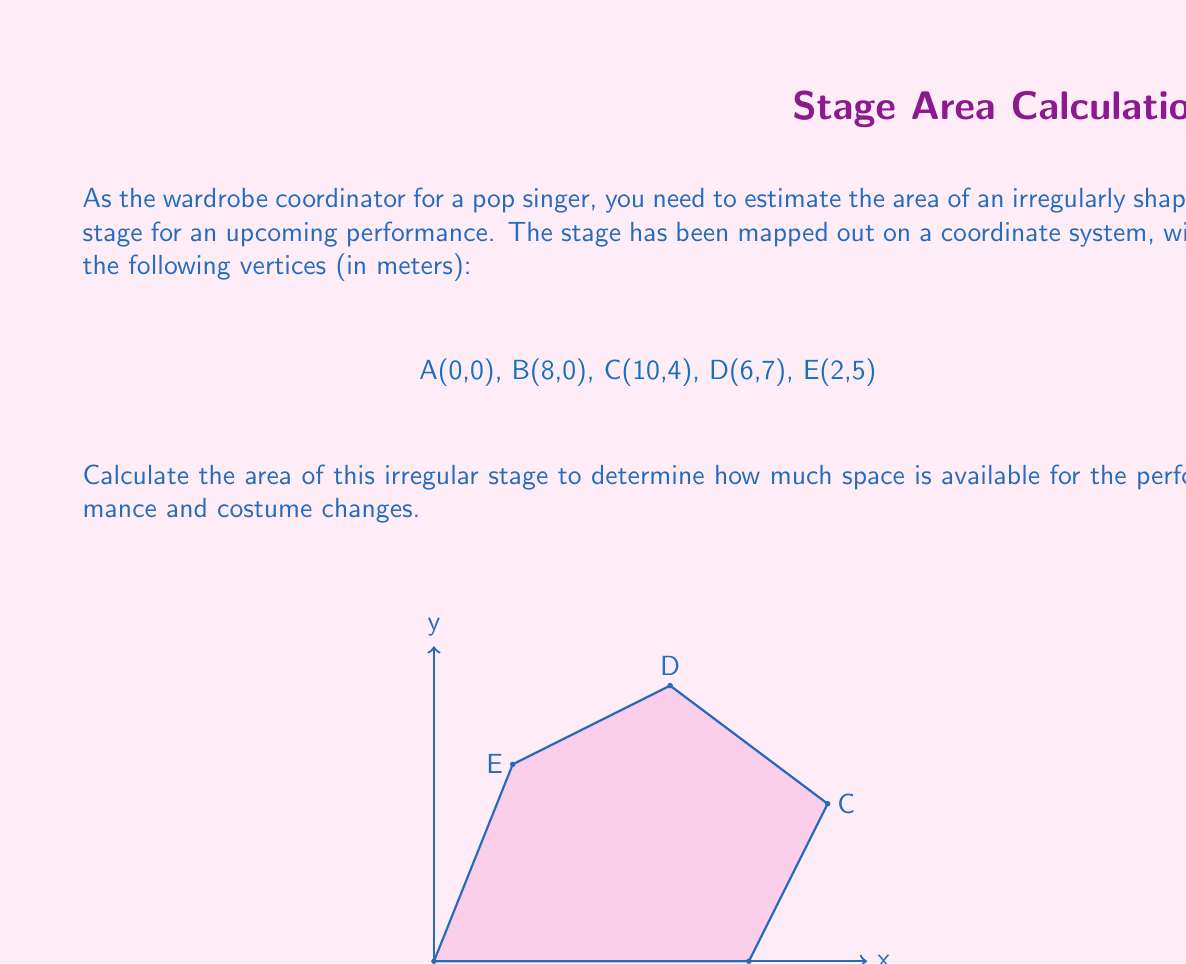Teach me how to tackle this problem. To calculate the area of this irregular polygon, we can use the Shoelace formula (also known as the surveyor's formula). The steps are as follows:

1) List the coordinates in order (clockwise or counterclockwise):
   (0,0), (8,0), (10,4), (6,7), (2,5)

2) Apply the Shoelace formula:
   $$ A = \frac{1}{2}|(x_1y_2 + x_2y_3 + ... + x_ny_1) - (y_1x_2 + y_2x_3 + ... + y_nx_1)| $$

3) Substitute the values:
   $$ A = \frac{1}{2}|(0 \cdot 0 + 8 \cdot 4 + 10 \cdot 7 + 6 \cdot 5 + 2 \cdot 0) - (0 \cdot 8 + 0 \cdot 10 + 4 \cdot 6 + 7 \cdot 2 + 5 \cdot 0)| $$

4) Calculate:
   $$ A = \frac{1}{2}|(0 + 32 + 70 + 30 + 0) - (0 + 0 + 24 + 14 + 0)| $$
   $$ A = \frac{1}{2}|132 - 38| $$
   $$ A = \frac{1}{2} \cdot 94 $$
   $$ A = 47 $$

Therefore, the area of the irregular stage is 47 square meters.
Answer: 47 m² 